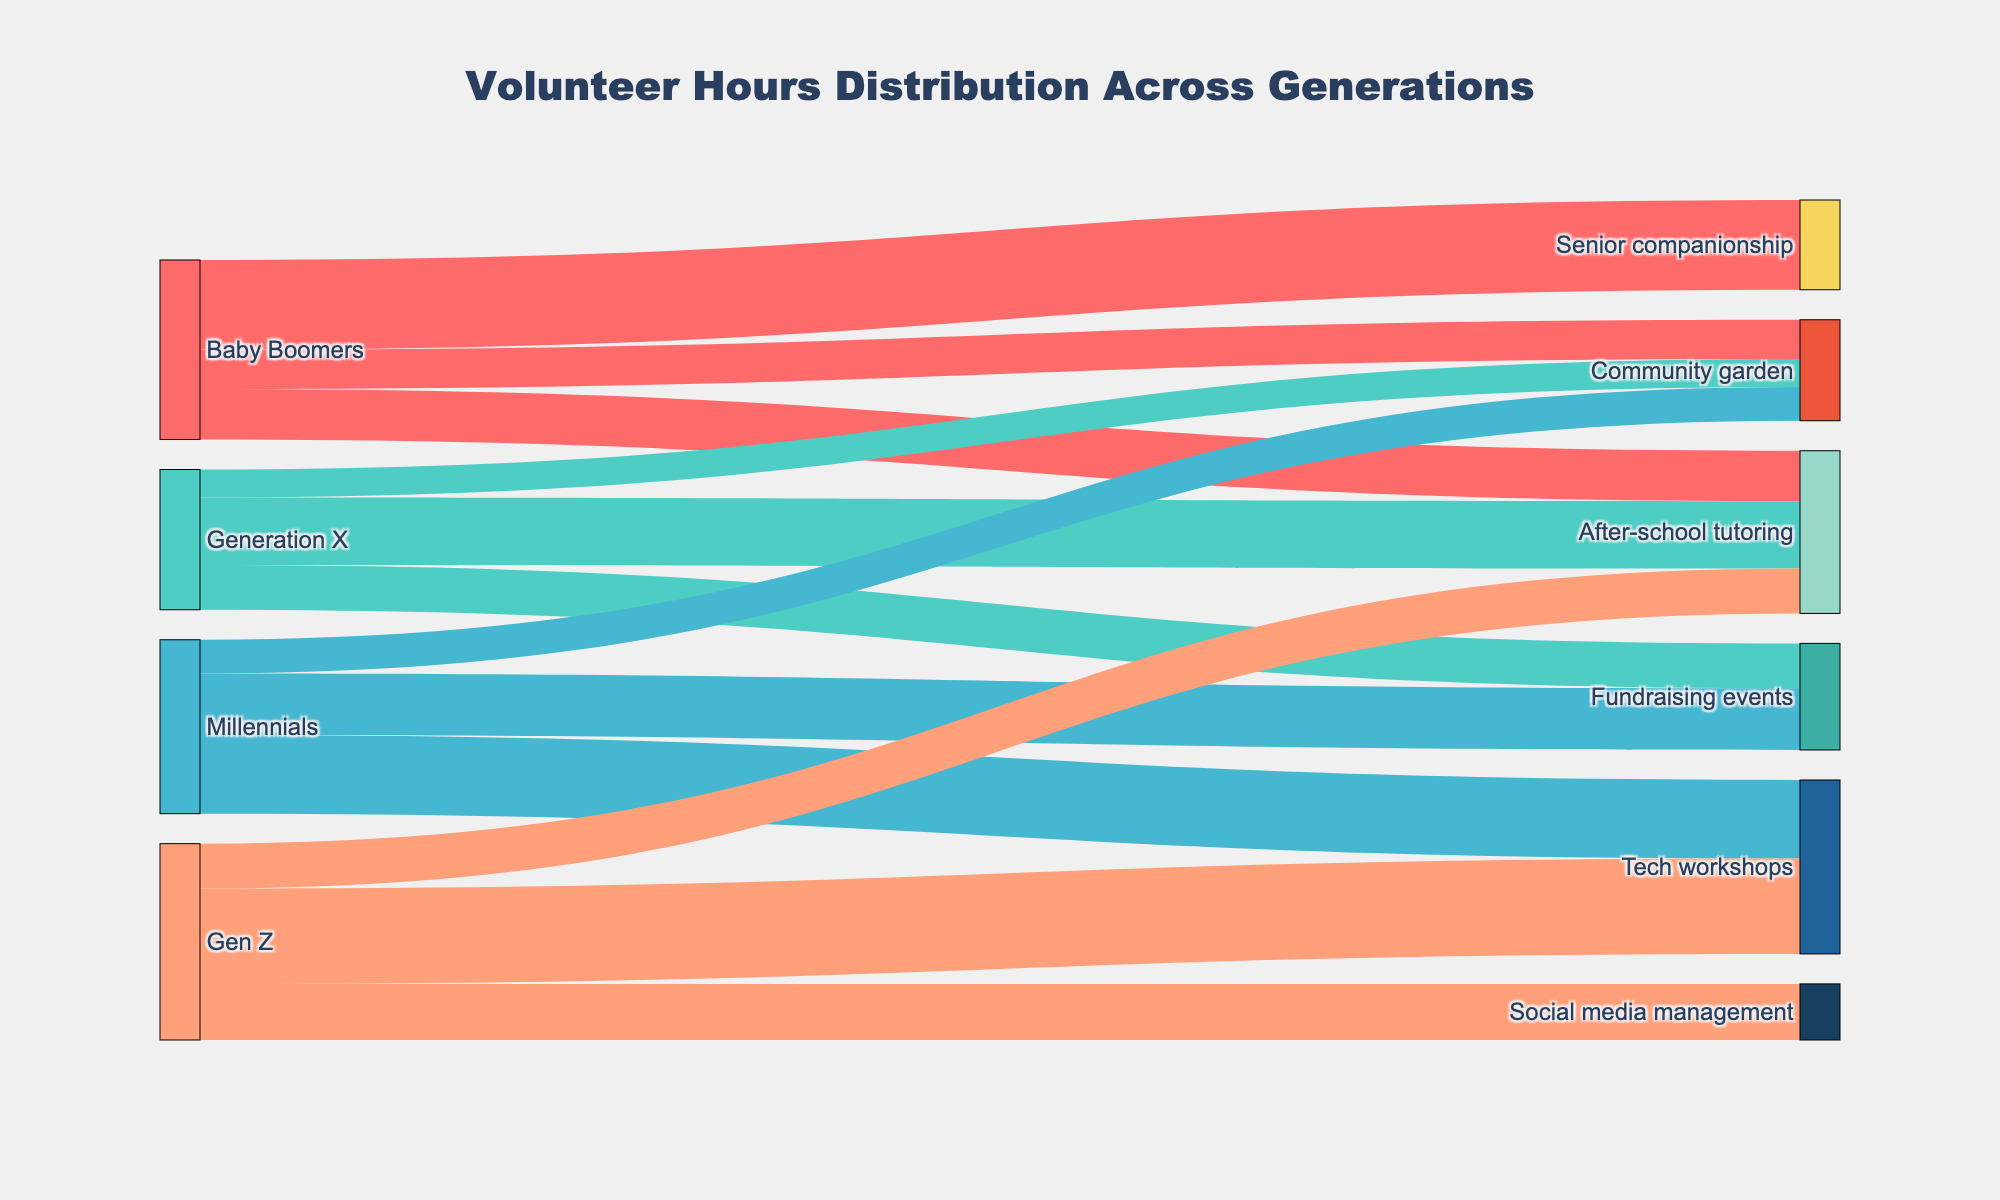which generation contributed the most hours to After-school tutoring? The Sankey diagram shows the flow of hours contributed by different generations to various activities. By looking at the width of the flow lines corresponding to After-school tutoring, we can see that Generation X contributed the most hours.
Answer: Generation X what is the total number of volunteer hours contributed by Millennials? To find the total number of volunteer hours contributed by Millennials, add up the values flowing from Millennials to all activities: 550 (Fundraising events) + 700 (Tech workshops) + 300 (Community garden).
Answer: 1550 which activity received the least volunteer hours from Baby Boomers? Examine the flow lines from Baby Boomers to different activities. The line widths indicate the number of hours contributed. The flow to Community garden is the thinnest, indicating it received 350 hours, the least among the listed activities.
Answer: Community garden how many more hours did Gen Z contribute to Tech workshops compared to Social media management? Gen Z contributed 850 hours to Tech workshops and 500 hours to Social media management. Subtract the hours for Social media management from Tech workshops: 850 - 500 = 350.
Answer: 350 which generation contributed the second-highest number of hours in total? Calculate the total number of hours contributed by each generation, and then determine the second-highest: Baby Boomers (450 + 800 + 350) = 1600, Generation X (600 + 400 + 250) = 1250, Millennials (550 + 700 + 300) = 1550, Gen Z (850 + 500 + 400) = 1750. Baby Boomers have the second-highest total.
Answer: Baby Boomers which activity received contributions from all four generations? By examining the flow lines, we can see which activities show connections from all different generations. After-school tutoring has flows from Baby Boomers, Generation X, Millennials, and Gen Z.
Answer: After-school tutoring what is the total number of volunteer hours contributed across all generations? Add up the contributions from each generation to all activities to get the total number: 450 + 800 + 350 + 600 + 400 + 250 + 550 + 700 + 300 + 850 + 500 + 400.
Answer: 6150 which generation contributed the least amount of hours to fundraising events? Examine the flow lines directed toward Fundraising events. Among the generations that contributed to this activity, Generation X contributed 400 hours, and Millennials contributed 550 hours. Generation X contributed the least.
Answer: Generation X 